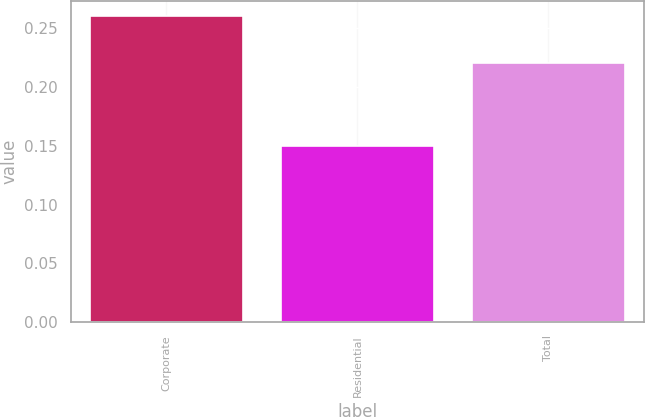<chart> <loc_0><loc_0><loc_500><loc_500><bar_chart><fcel>Corporate<fcel>Residential<fcel>Total<nl><fcel>0.26<fcel>0.15<fcel>0.22<nl></chart> 